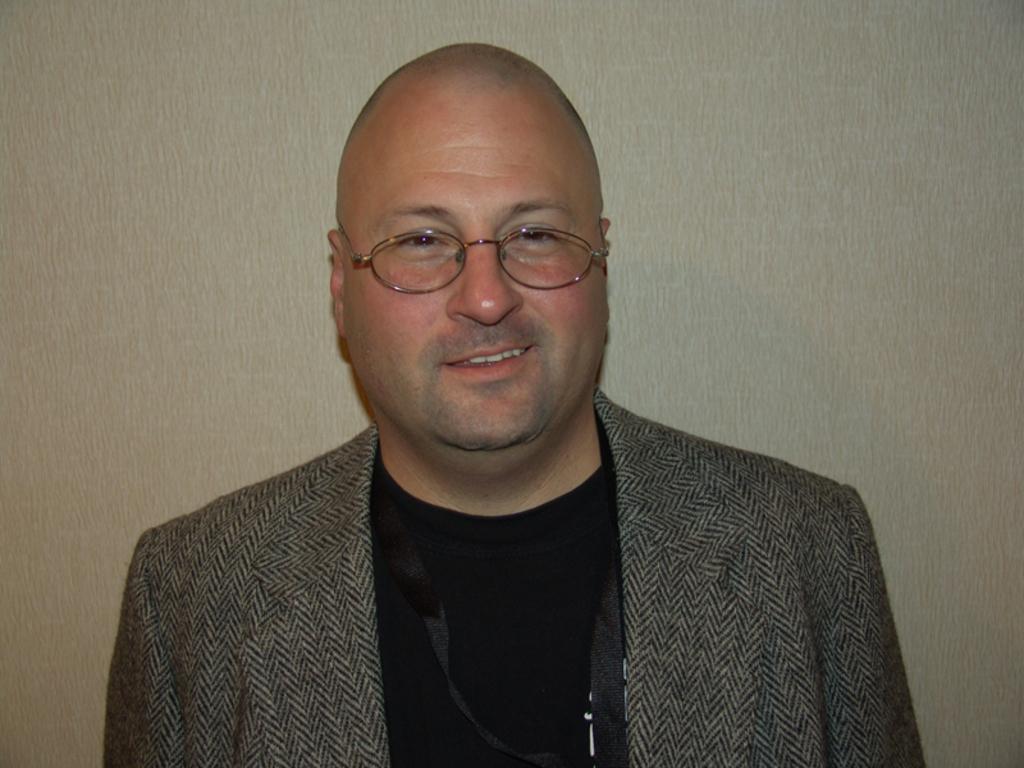Can you describe this image briefly? In this picture there is a man who is wearing black t-shirt, grey blazer and sweater. He is standing near to the wall. 